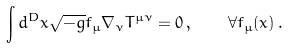<formula> <loc_0><loc_0><loc_500><loc_500>\int d ^ { D } x \sqrt { - g } f _ { \mu } \nabla _ { \nu } T ^ { \mu \nu } = 0 \, , \quad \forall f _ { \mu } ( x ) \, .</formula> 